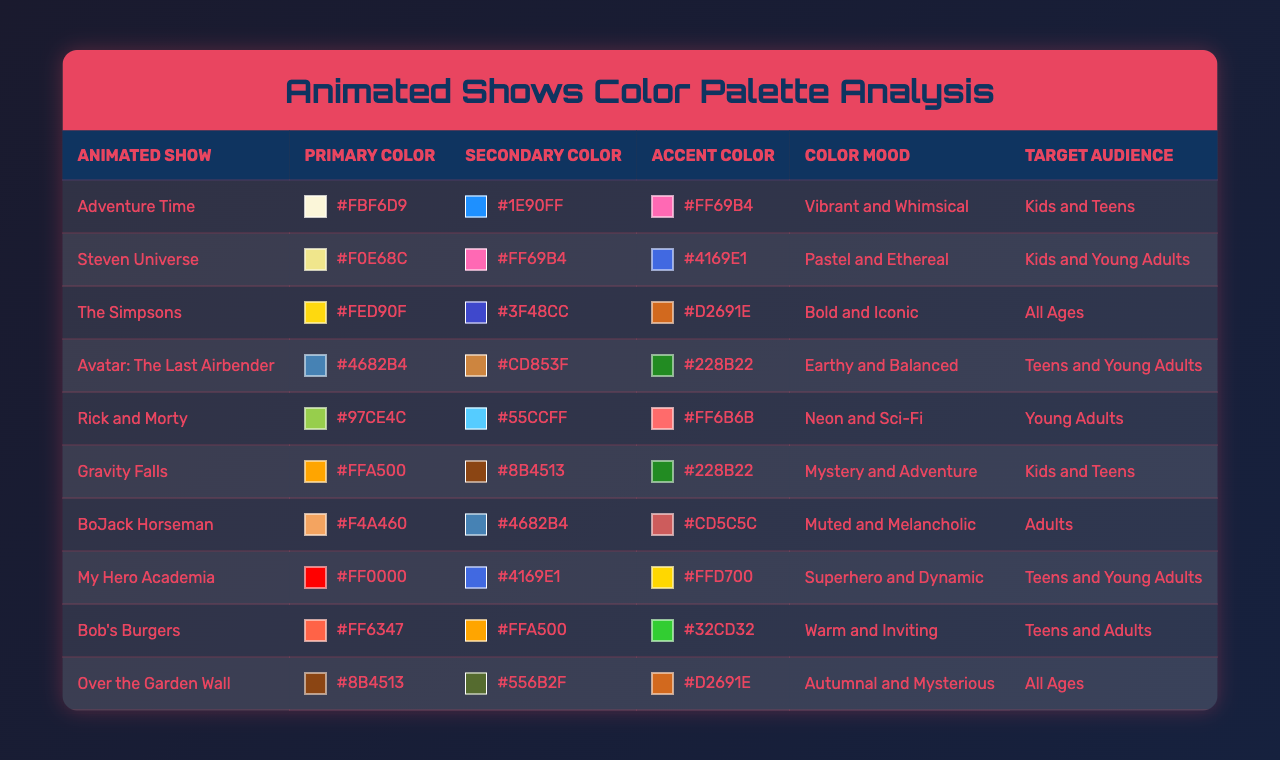What is the primary color of "Adventure Time"? The table shows the primary color associated with "Adventure Time" is listed under the "Primary Color" column next to the show's name. The color is #FBF6D9.
Answer: #FBF6D9 Which show has a secondary color of #FF69B4? By scanning the "Secondary Color" column for the color #FF69B4, we can find that both "Steven Universe" and "Adventure Time" have that color listed.
Answer: Steven Universe, Adventure Time What is the accent color of "Avatar: The Last Airbender"? According to the table, the accent color corresponding to "Avatar: The Last Airbender" is found in the "Accent Color" column next to the show's name. It is #228B22.
Answer: #228B22 Which animated show is aimed at "Kids and Teens" and has an earthy color mood? We can search the "Target Audience" column for "Kids and Teens" and check the corresponding "Color Mood". "Gravity Falls" has a "Mystery and Adventure" mood, while "Adventure Time" has a "Vibrant and Whimsical" mood. "Avatar: The Last Airbender" has an "Earthy and Balanced" mood and fits the target audience.
Answer: Avatar: The Last Airbender Are any of the shows targeting "Adults" using a vibrant color mood? The only show targeting "Adults" is "BoJack Horseman", which has a "Muted and Melancholic" color mood, therefore there are no shows targeting adults with a vibrant mood.
Answer: No What is the average primary color hex code for the shows aimed at "Teens and Young Adults"? The shows targeting "Teens and Young Adults" include "Avatar: The Last Airbender," "My Hero Academia," and "Steven Universe." Their primary colors are #4682B4, #FF0000, and #F0E68C respectively. Hex values cannot be numerically averaged in a conventional sense, but we can note their colors.
Answer: Not applicable Which show has the most iconic color palette, and what is that palette's primary color? The table indicates that "The Simpsons" is referred to as "Bold and Iconic", and the corresponding primary color listed is #FED90F.
Answer: The Simpsons, #FED90F If I wanted to appeal to "Kids and Young Adults," which show's color palette should I consider? Looking at the target audience of "Kids and Young Adults," both "Steven Universe" and "My Hero Academia" are applicable. Steven Universe has pastel colors while My Hero Academia has dynamic superhero colors.
Answer: Steven Universe or My Hero Academia What color mood does "Rick and Morty" have? The desired information can be retrieved from the "Color Mood" column for "Rick and Morty". It is indicated as "Neon and Sci-Fi".
Answer: Neon and Sci-Fi How many different secondary colors are represented in shows aimed at "All Ages"? From the table, we see that there are two shows targeting "All Ages," namely "The Simpsons" and "Over the Garden Wall." Their secondary colors are #3F48CC and #556B2F, respectively, which makes two unique secondary colors.
Answer: 2 